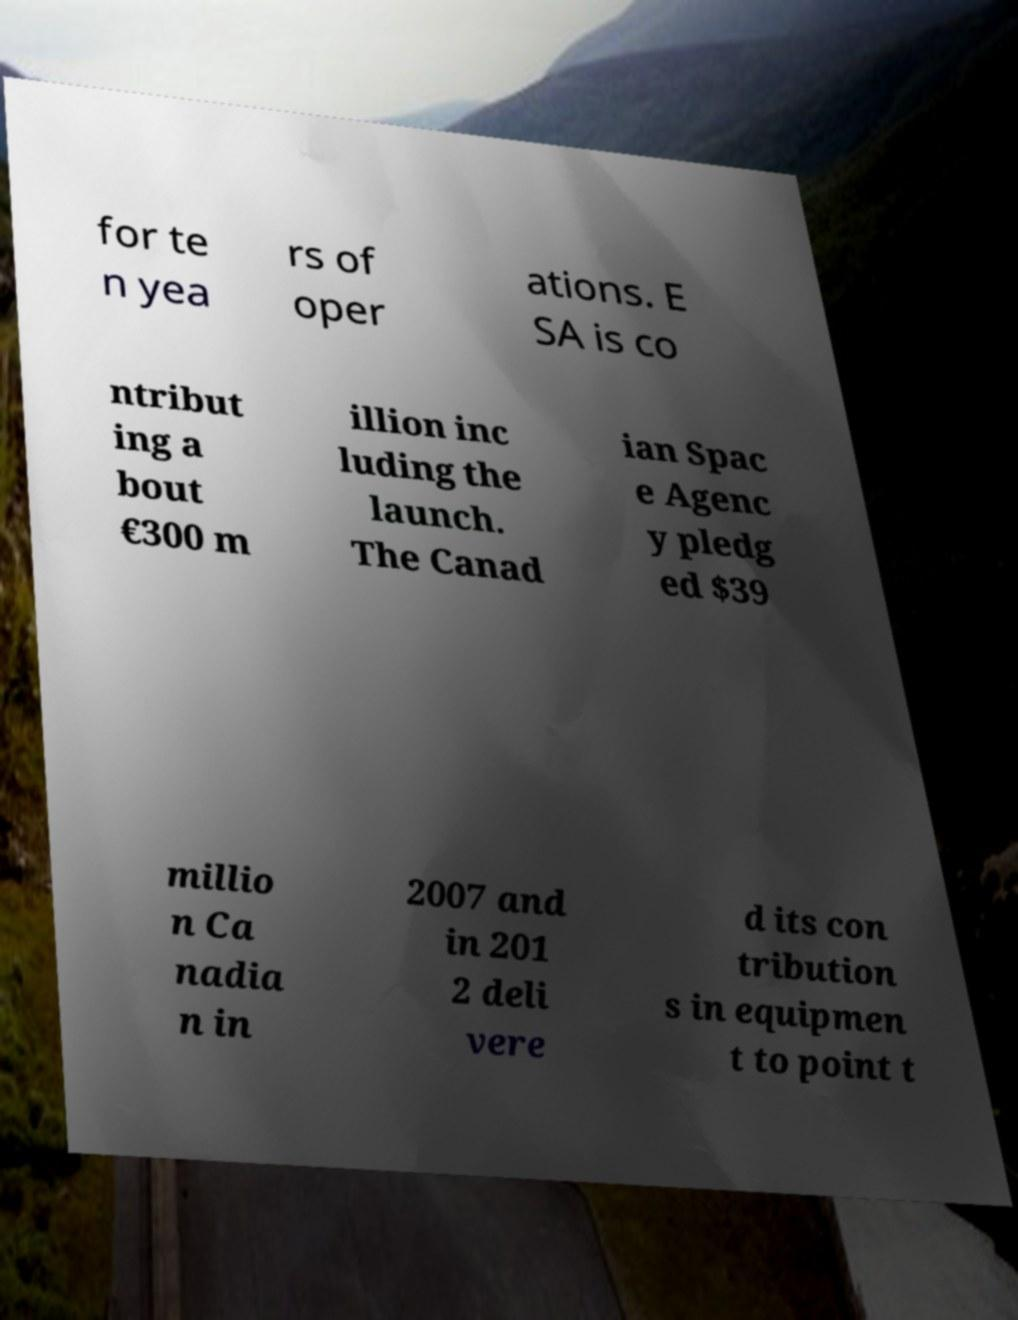Please identify and transcribe the text found in this image. for te n yea rs of oper ations. E SA is co ntribut ing a bout €300 m illion inc luding the launch. The Canad ian Spac e Agenc y pledg ed $39 millio n Ca nadia n in 2007 and in 201 2 deli vere d its con tribution s in equipmen t to point t 